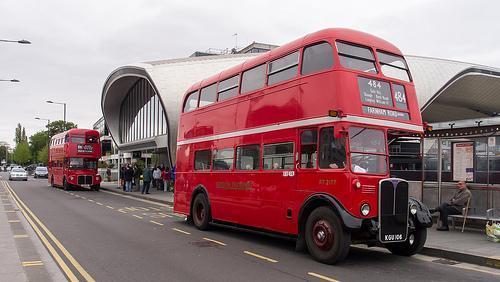How many busses are there?
Give a very brief answer. 2. How many small cars are in the image?
Give a very brief answer. 2. 